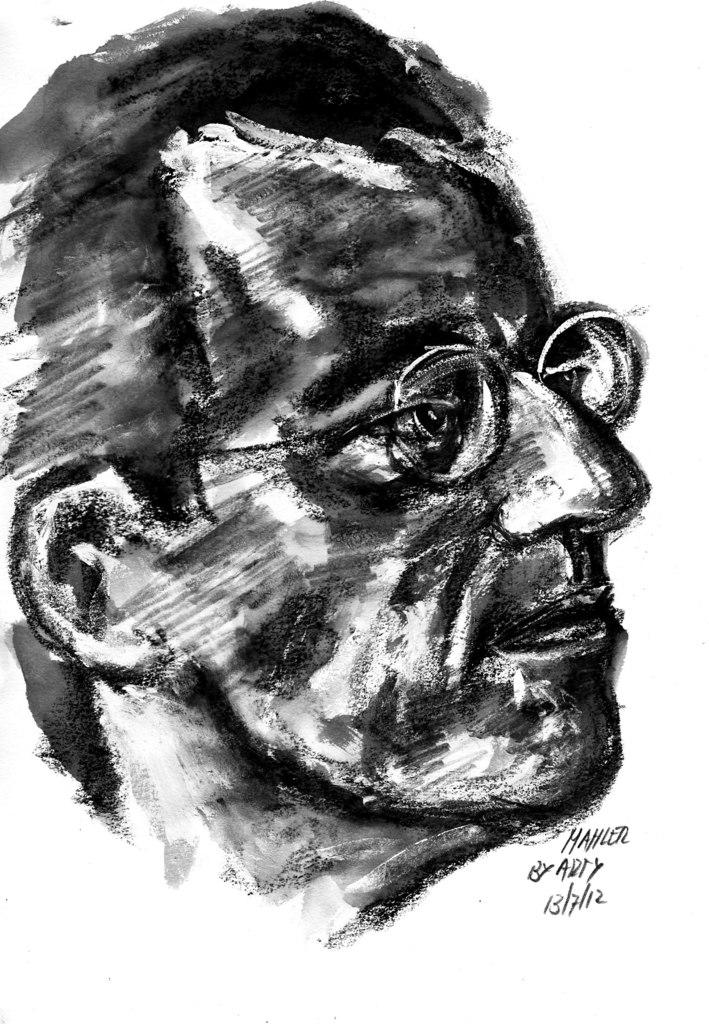What is the main subject of the image? There is a sketch of a person in the image. Are there any words or letters in the image? Yes, there is text in the image. What color is the background of the image? The background of the image is white. Can you see a toad sitting on the person's shoulder in the image? No, there is no toad present in the image. What type of food is the person holding in the image? There is no food visible in the image; it only features a sketch of a person and text. 